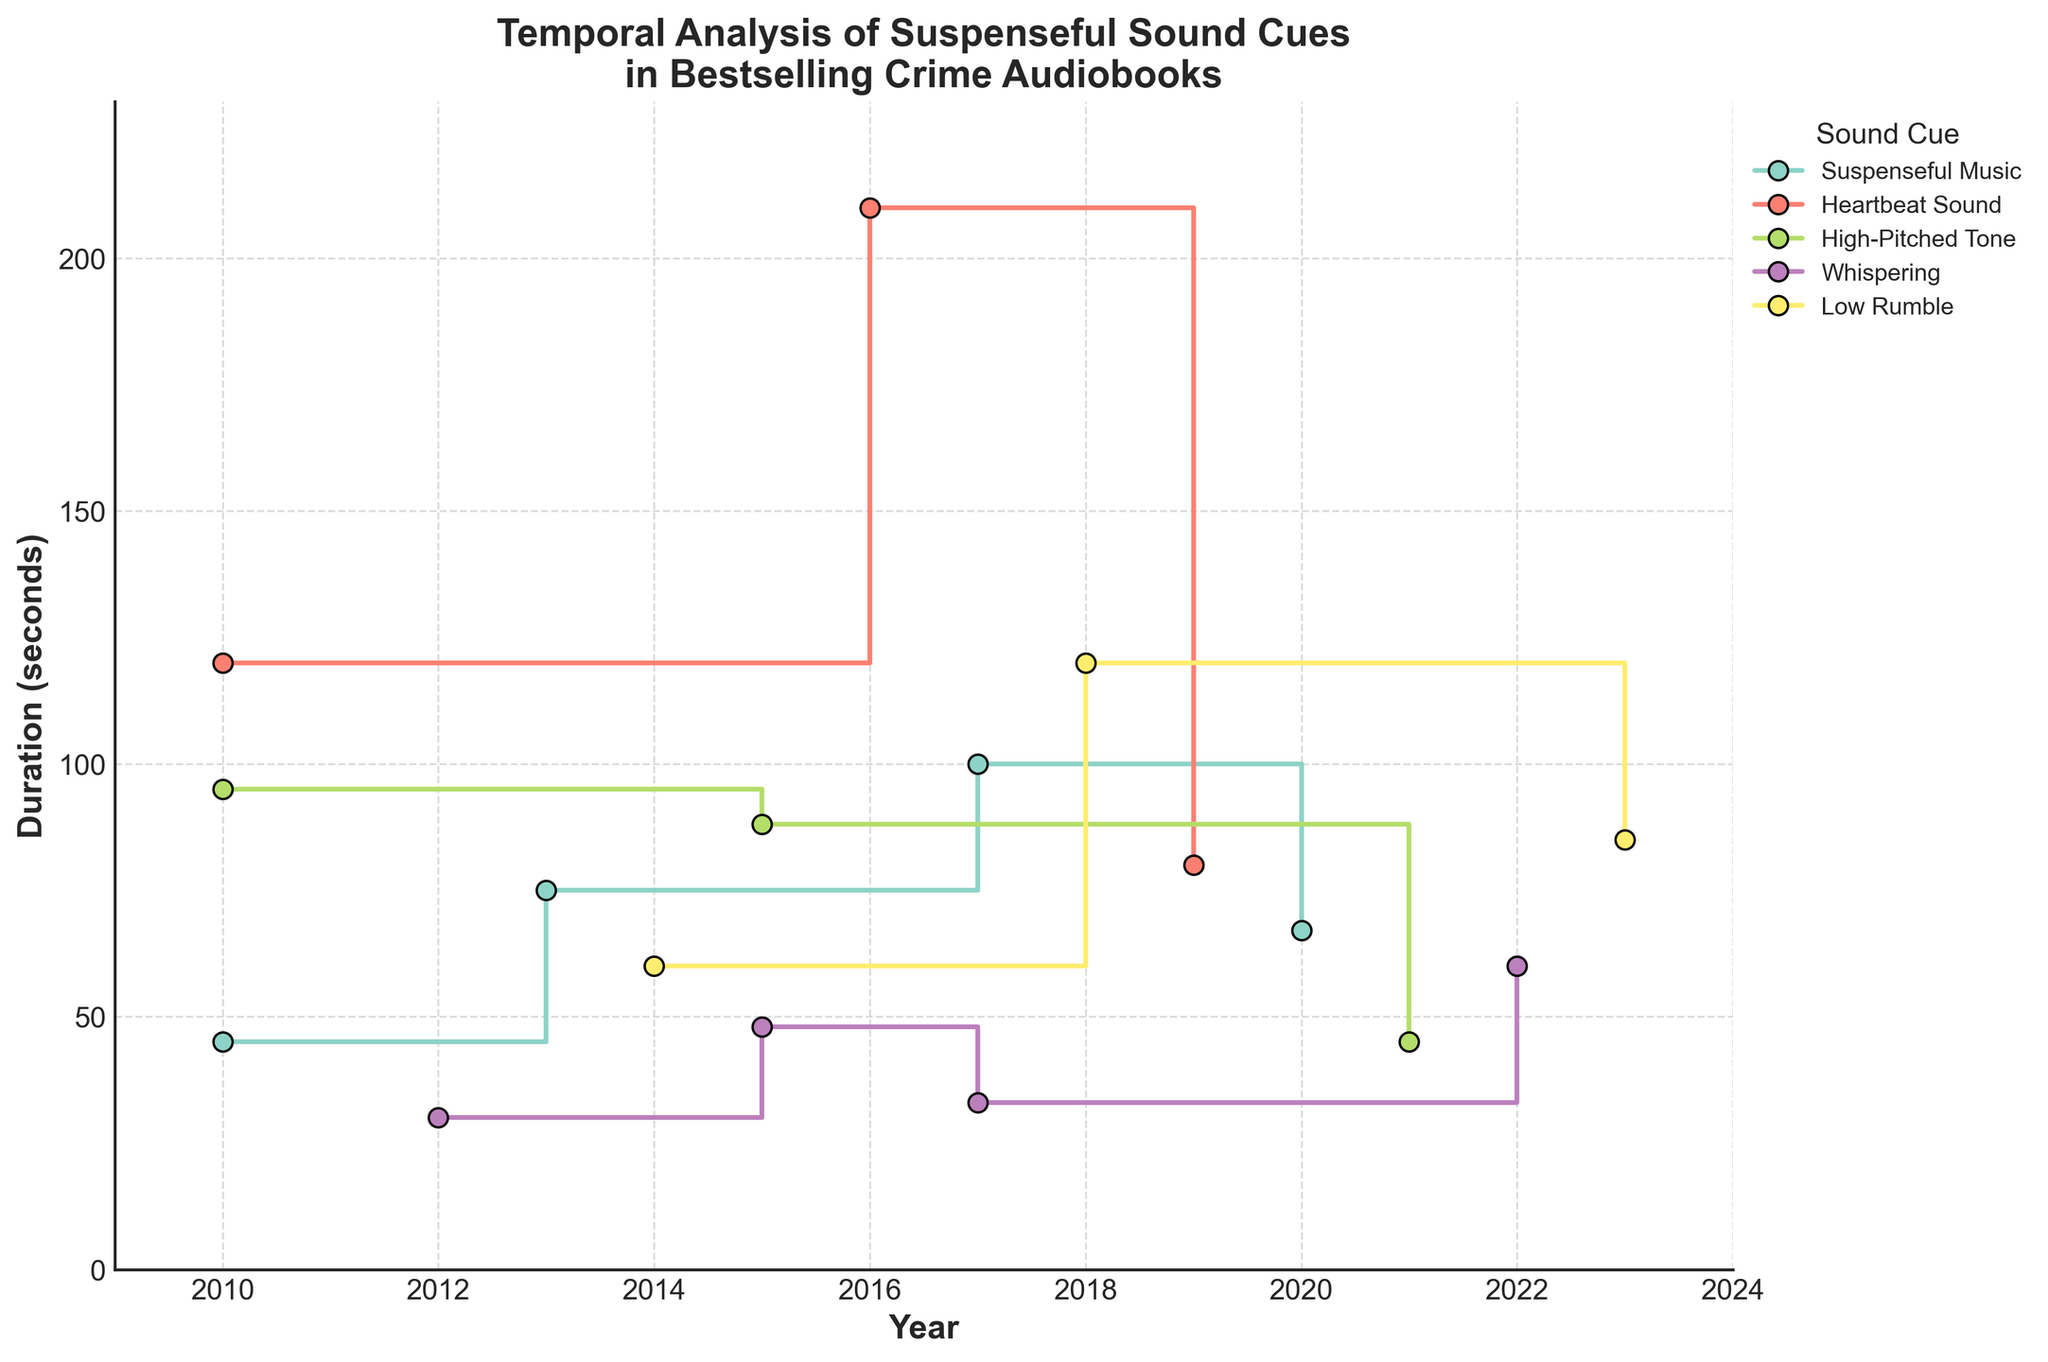What's the title of the plot? The title is displayed at the top of the plot. It reads "Temporal Analysis of Suspenseful Sound Cues in Bestselling Crime Audiobooks".
Answer: Temporal Analysis of Suspenseful Sound Cues in Bestselling Crime Audiobooks What is the range of years displayed on the x-axis? The x-axis shows the years ranging from 2010 to 2023.
Answer: 2010 to 2023 Which sound cue has the highest duration and in which year does it occur? By looking at the highest data point in the plot, we can see that "Heartbeat Sound" has the highest duration of 210 seconds in the year 2016.
Answer: Heartbeat Sound, 2016 How many unique sound cues are represented in the plot? The legend displays all the unique sound cues. Counting them gives a total of 6 unique sound cues.
Answer: 6 Which sound cue has the most entries over time? Referring to the data points for each sound cue and counting them, "Suspenseful Music" has the most entries with four data points.
Answer: Suspenseful Music What is the duration of "Low Rumble" sound cue in 2023, and how does it compare to its duration in 2014? "Low Rumble" has a duration of 85 seconds in 2023 and 60 seconds in 2014. The difference is 85 - 60 = 25 seconds.
Answer: 85 seconds in 2023, 25 seconds more than in 2014 Which year recorded the lowest duration for "Whispering," and what is this duration? By looking at the data points for "Whispering," the year with the lowest duration is 2012 with 30 seconds.
Answer: 2012, 30 seconds Between 2015 and 2020, how many times was "High-Pitched Tone" used? Counting the data points for "High-Pitched Tone" within these years, it appears two times, in 2015 and 2021.
Answer: 2 times In which years did "Suspenseful Music" appear, and what were the durations for each year? According to the plot, "Suspenseful Music" appears in 2010 (45 seconds), 2013 (75 seconds), 2017 (100 seconds), and 2020 (67 seconds).
Answer: 2010 (45 seconds), 2013 (75 seconds), 2017 (100 seconds), 2020 (67 seconds) What's the overall trend for the "Heartbeat Sound" over the years displayed? Observing the "Heartbeat Sound" data points shows that the duration initially increases from 2010 (120 seconds) to 2016 (210 seconds) and then decreases in 2019 (80 seconds).
Answer: Increase then decrease 